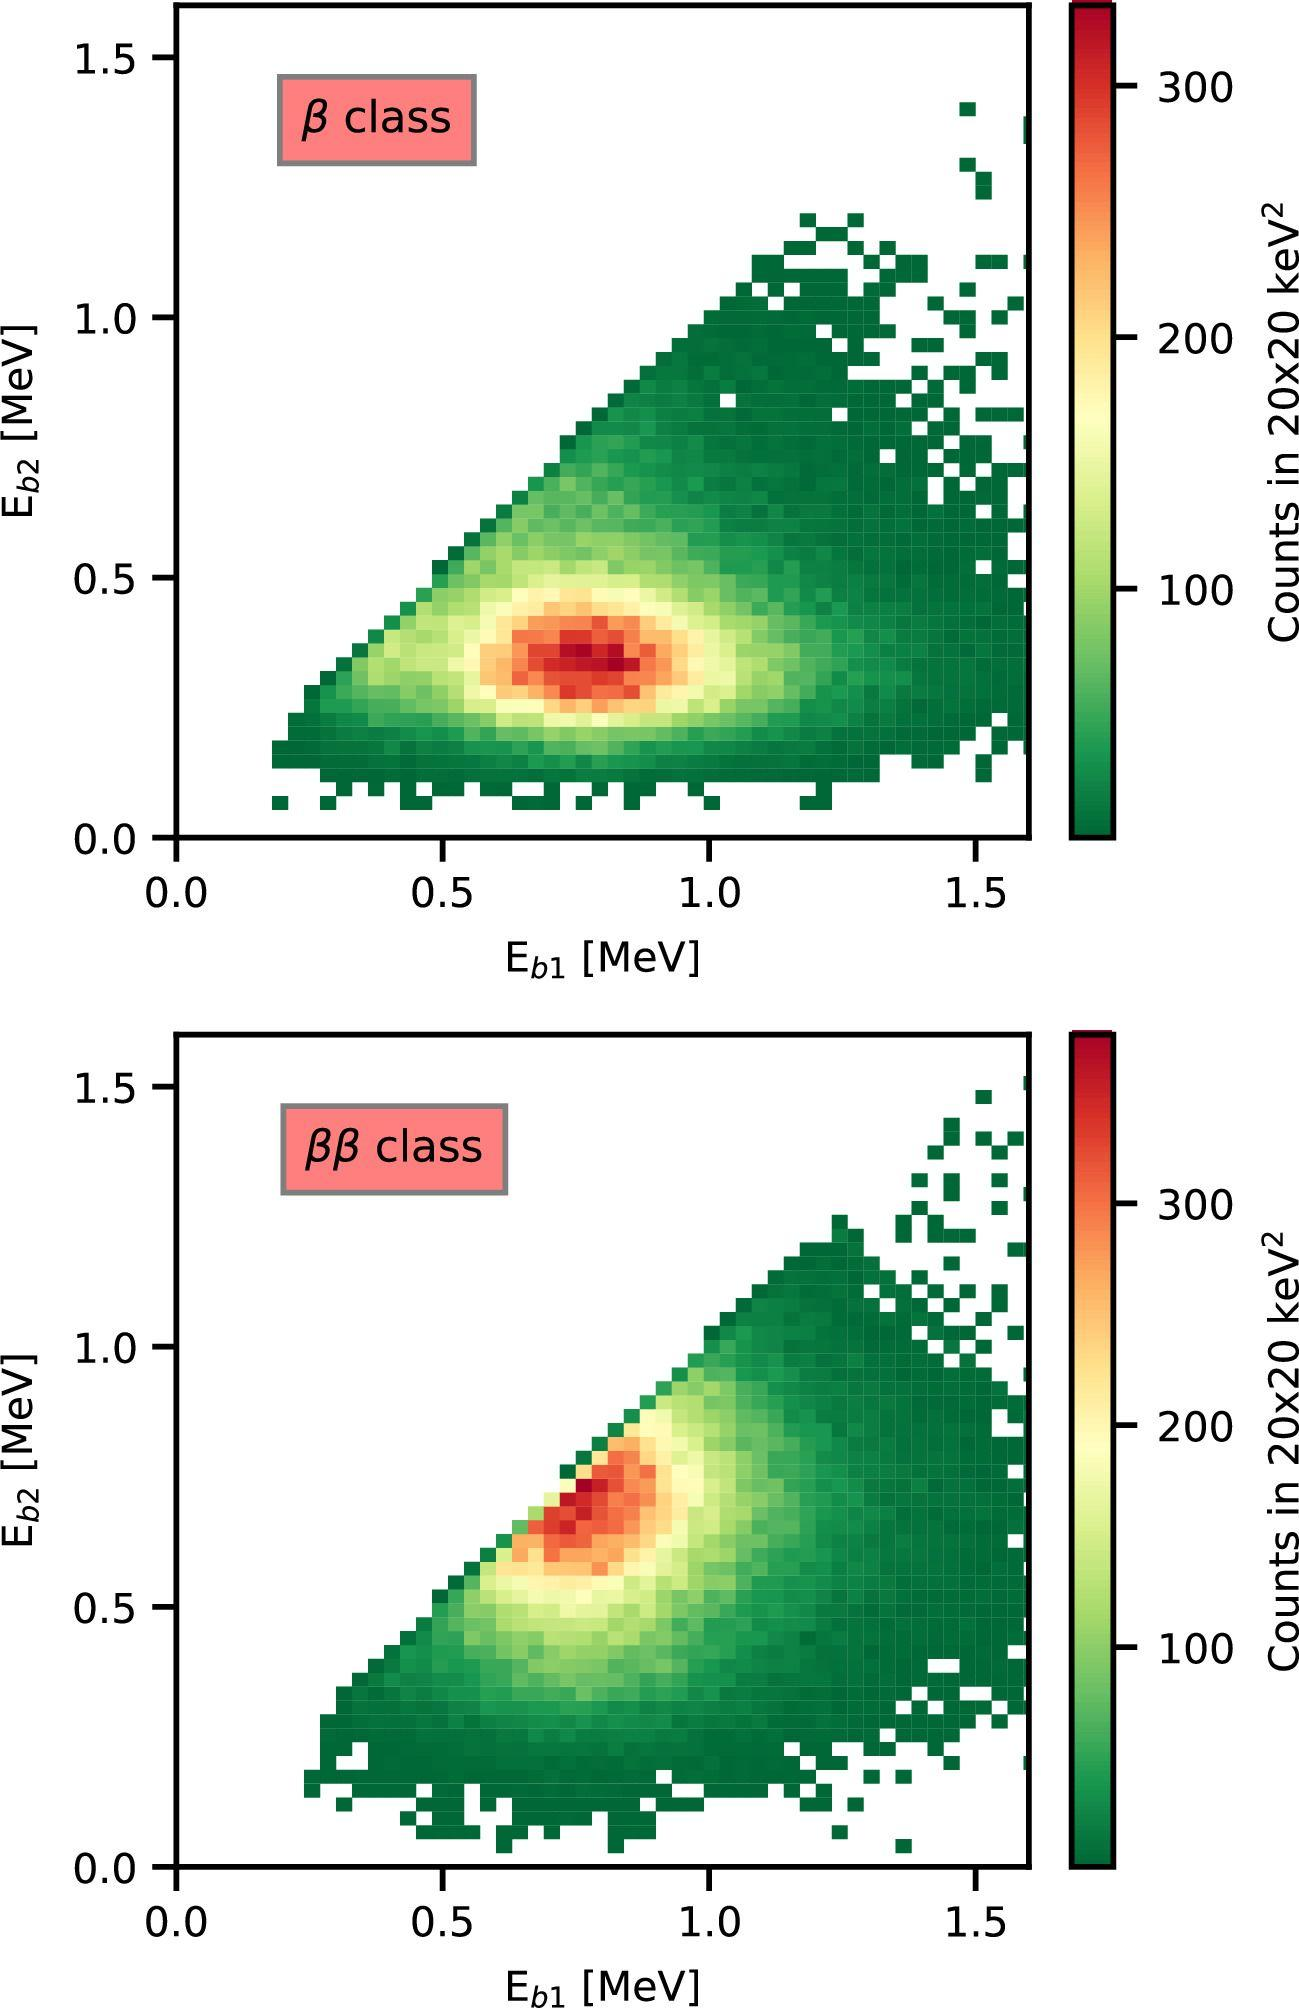Based on the color intensity in the figures, where is the highest concentration of data points found? A) In the lower left corner of each figure B) Along the diagonal from the lower left to upper right corner C) In the upper right corner of each figure D) Evenly distributed throughout each figure The color intensity is highest along the diagonal line, indicating a greater number of counts (as per the color bar indicating 'Counts in 2020 keV^2') along that line in both figures. Therefore, the correct answer is B) Along the diagonal from the lower left to upper right corner. 